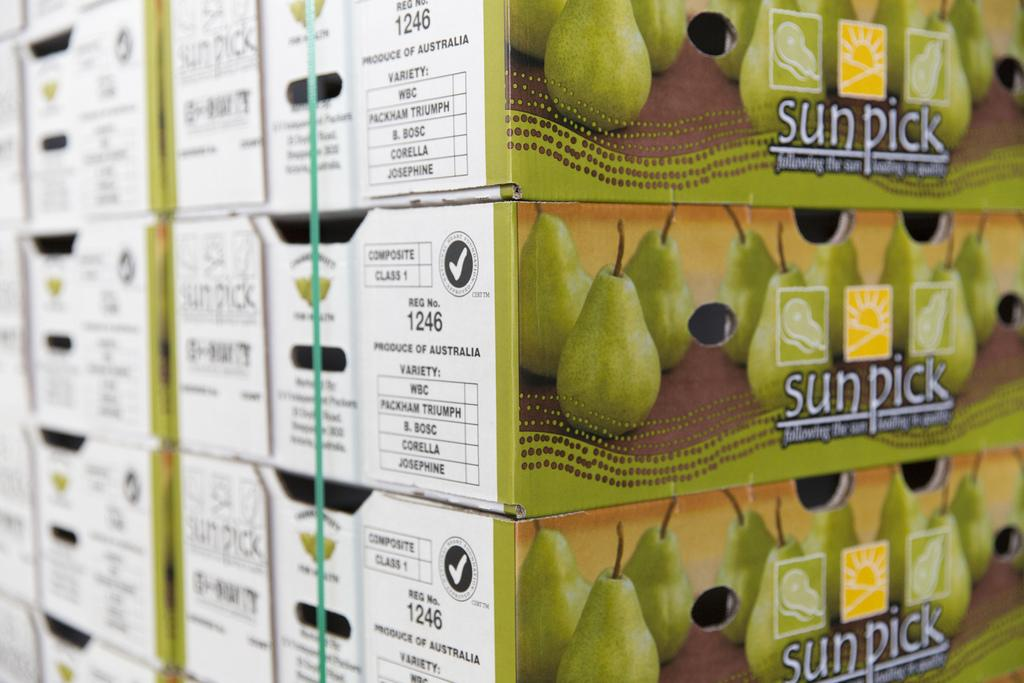What objects are present in the image? There are boxes in the image. What is placed on top of the boxes? There are fruits on the boxes. What information is provided on the boxes? There is text on the boxes. What type of dress is hanging in the cellar in the image? There is no dress or cellar present in the image; it only features boxes with fruits and text. 